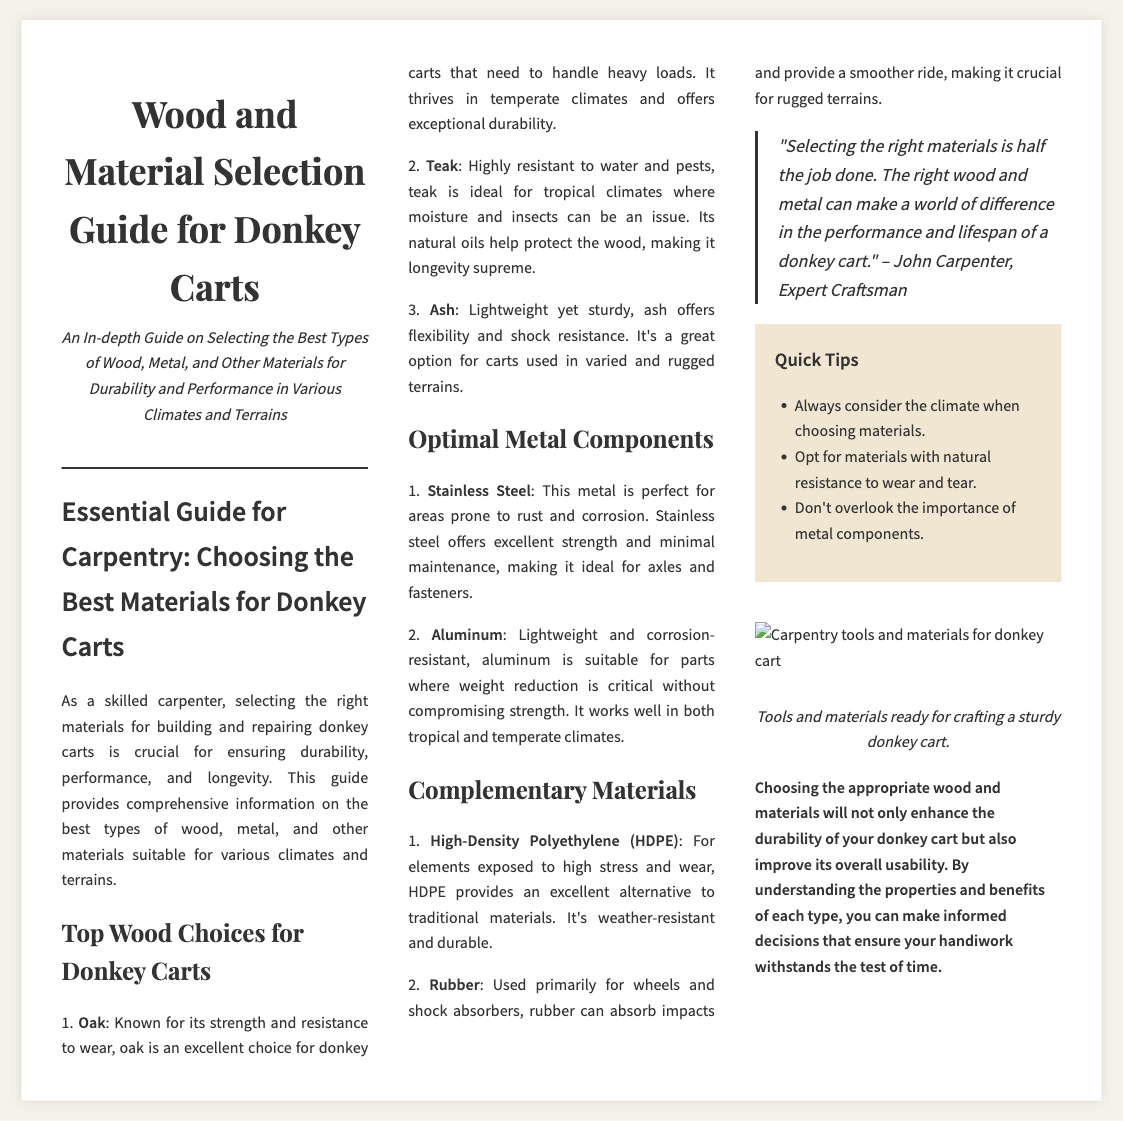What is the title of the document? The title clearly states the document's focus on wood and material selection for donkey carts.
Answer: Wood and Material Selection Guide for Donkey Carts What wood is known for its strength and resistance to wear? The document specifically lists wood types, with oak being noted for its strength.
Answer: Oak Which metal is ideal for areas prone to rust? The document mentions the optimal metal components, highlighting stainless steel for rust-prone areas.
Answer: Stainless Steel What material is highly resistant to water and pests? Teak is identified in the document as highly resistant to water and pests.
Answer: Teak Which component provides a smoother ride in rugged terrains? The document discusses rubber as a key material for smoother rides and shock absorption.
Answer: Rubber What is the main focus of the guide? The guide aims to provide information on selecting suitable materials for durability and performance.
Answer: Selecting the best types of wood, metal, and other materials for durability and performance What type of wood is lightweight yet sturdy? The document describes ash as a lightweight yet sturdy option for carts.
Answer: Ash What is a quick tip mentioned in the sidebar? The sidebar lists important considerations for material selection, including climate considerations.
Answer: Always consider the climate when choosing materials Who is quoted in the document regarding material selection? The document attributes the quote about material selection to John Carpenter.
Answer: John Carpenter 